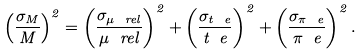<formula> <loc_0><loc_0><loc_500><loc_500>\left ( \frac { \sigma _ { M } } { M } \right ) ^ { 2 } = \left ( \frac { \sigma _ { \mu _ { \ } r e l } } { \mu _ { \ } r e l } \right ) ^ { 2 } + \left ( \frac { \sigma _ { t _ { \ } e } } { t _ { \ } e } \right ) ^ { 2 } + \left ( \frac { \sigma _ { \pi _ { \ } e } } { \pi _ { \ } e } \right ) ^ { 2 } .</formula> 